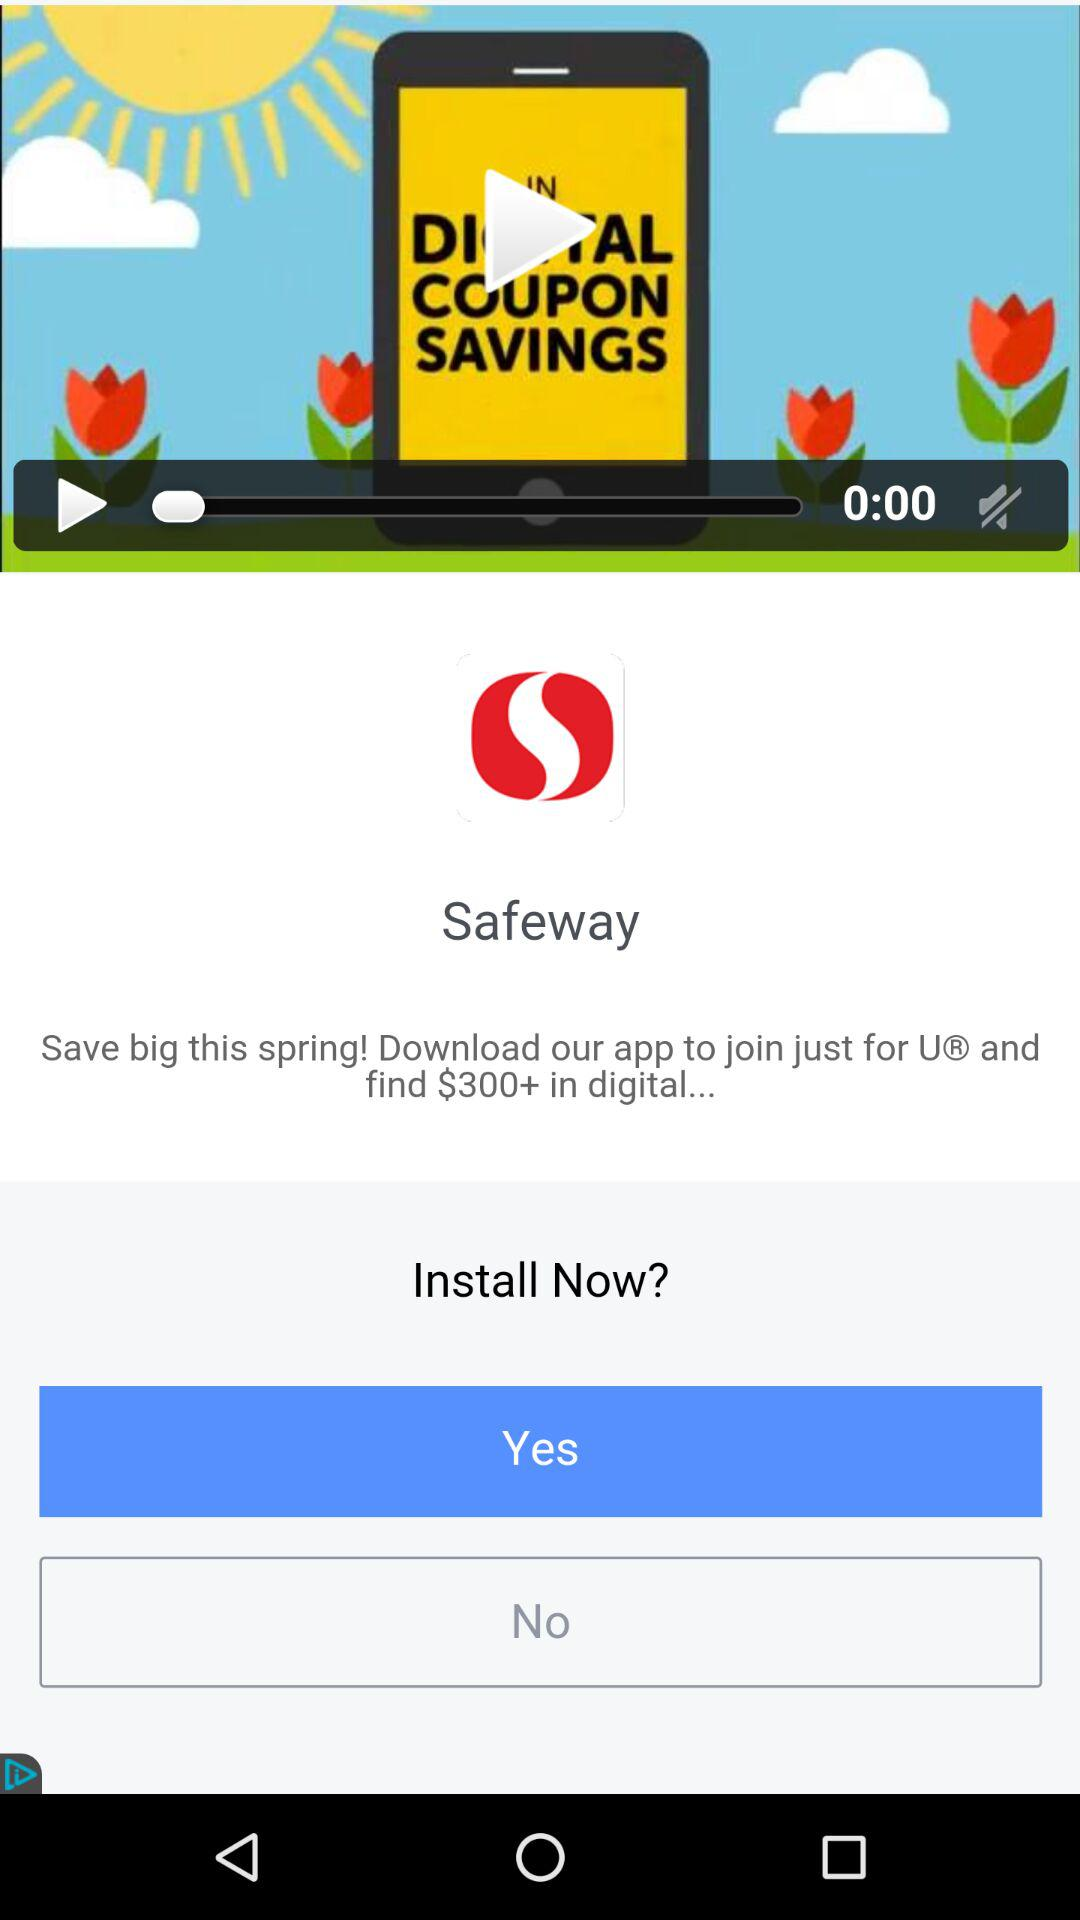How many dollars of digital coupons can I save by downloading the app?
Answer the question using a single word or phrase. $300+ 